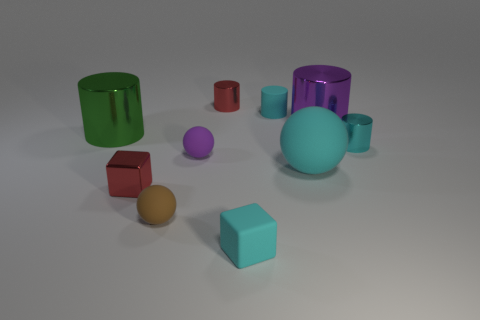Is the number of purple matte objects in front of the matte block the same as the number of red blocks behind the tiny red cylinder?
Make the answer very short. Yes. Does the cube that is on the left side of the small red shiny cylinder have the same color as the small sphere that is right of the small brown thing?
Give a very brief answer. No. Is the number of cyan spheres that are in front of the shiny block greater than the number of small things?
Keep it short and to the point. No. There is a brown thing that is the same material as the small purple sphere; what shape is it?
Offer a terse response. Sphere. There is a cyan matte object that is in front of the red metallic cube; is it the same size as the metallic block?
Your answer should be very brief. Yes. There is a small red thing on the left side of the red thing that is to the right of the brown sphere; what is its shape?
Your response must be concise. Cube. How big is the cyan thing that is behind the cyan cylinder that is right of the tiny matte cylinder?
Provide a succinct answer. Small. What color is the tiny shiny thing left of the small red cylinder?
Your answer should be compact. Red. What size is the cyan object that is the same material as the green cylinder?
Provide a succinct answer. Small. How many cyan rubber things have the same shape as the brown thing?
Ensure brevity in your answer.  1. 